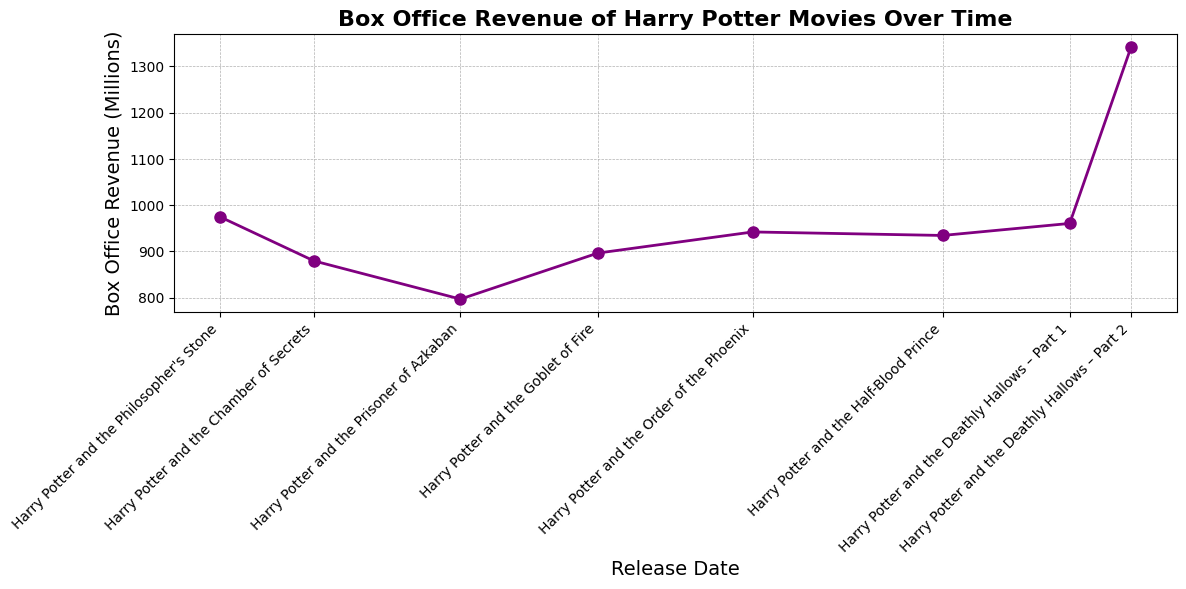What is the total box office revenue for all the Harry Potter movies combined? First, sum up the box office revenue of all the movies: 974.76 + 879.46 + 796.9 + 896.37 + 942.04 + 934.45 + 960.43 + 1342.35 = 7726.76 million dollars.
Answer: 7726.76 million dollars Which movie has the highest box office revenue? Look at the highest point on the line chart and identify the corresponding movie. The highest point is for "Harry Potter and the Deathly Hallows – Part 2" with a box office revenue of 1342.35 million dollars.
Answer: Harry Potter and the Deathly Hallows – Part 2 How many movies have a box office revenue higher than 900 million dollars? Identify all the movies with revenues exceeding 900 million dollars by checking the y-values: The movies are "Harry Potter and the Philosopher's Stone" (974.76), "Harry Potter and the Order of the Phoenix" (942.04), "Harry Potter and the Half-Blood Prince" (934.45), "Harry Potter and the Deathly Hallows – Part 1" (960.43), and "Harry Potter and the Deathly Hallows – Part 2" (1342.35). There are 5 such movies.
Answer: 5 What is the difference in box office revenue between the least and the most successful Harry Potter movies? Identify the least and most successful movies: "Harry Potter and the Prisoner of Azkaban" (796.9) and "Harry Potter and the Deathly Hallows – Part 2" (1342.35), respectively. Calculate the difference: 1342.35 - 796.9 = 545.45 million dollars.
Answer: 545.45 million dollars Which two consecutive movies have the smallest increase in box office revenue? Calculate the increase in revenue for each pair of consecutive movies:
- Philosopher's Stone to Chamber of Secrets: 879.46 - 974.76 = -95.3
- Chamber of Secrets to Prisoner of Azkaban: 796.9 - 879.46 = -82.56
- Prisoner of Azkaban to Goblet of Fire: 896.37 - 796.9 = 99.47
- Goblet of Fire to Order of the Phoenix: 942.04 - 896.37 = 45.67
- Order of the Phoenix to Half-Blood Prince: 934.45 - 942.04 = -7.59
- Half-Blood Prince to Deathly Hallows Part 1: 960.43 - 934.45 = 25.98
- Deathly Hallows Part 1 to Deathly Hallows Part 2: 1342.35 - 960.43 = 381.92
The smallest increase is between "Order of the Phoenix" and "Half-Blood Prince" with -7.59 million dollars.
Answer: Order of the Phoenix and Half-Blood Prince What is the average box office revenue of the Harry Potter movies? Sum the revenues of all movies: 974.76 + 879.46 + 796.9 + 896.37 + 942.04 + 934.45 + 960.43 + 1342.35 = 7726.76 million dollars. Divide by the number of movies, which is 8: 7726.76 / 8 = 965.845 million dollars.
Answer: 965.845 million dollars How does the box office revenue of "Harry Potter and the Half-Blood Prince" compare to "Harry Potter and the Order of the Phoenix"? Identify the revenues for both movies: "Harry Potter and the Half-Blood Prince" (934.45) and "Harry Potter and the Order of the Phoenix" (942.04). The revenue for "Order of the Phoenix" is slightly higher.
Answer: "Order of the Phoenix" has a higher revenue than "Half-Blood Prince" Between which two years was the largest increase in box office revenue observed? Calculate the increase in revenue for each pair of consecutive years:
- 2001 to 2002: 879.46 - 974.76 = -95.3
- 2002 to 2004: 796.9 - 879.46 = -82.56
- 2004 to 2005: 896.37 - 796.9 = 99.47
- 2005 to 2007: 942.04 - 896.37 = 45.67
- 2007 to 2009: 934.45 - 942.04 = -7.59
- 2009 to 2010: 960.43 - 934.45 = 25.98
- 2010 to 2011: 1342.35 - 960.43 = 381.92
The largest increase is between 2010 and 2011 with an increase of 381.92 million dollars.
Answer: 2010 to 2011 What is the median box office revenue of all the Harry Potter movies? To find the median, organize the revenues in ascending order: 796.9, 879.46, 896.37, 934.45, 942.04, 960.43, 974.76, 1342.35. With 8 values, the median is the average of the 4th and 5th values: (934.45 + 942.04) / 2 = 938.245 million dollars.
Answer: 938.245 million dollars 